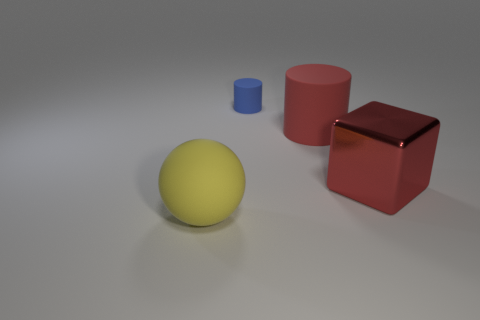What is the color of the matte object that is left of the big red cylinder and in front of the small thing?
Provide a short and direct response. Yellow. What number of other things are there of the same shape as the large yellow thing?
Your answer should be compact. 0. There is a big matte thing behind the red metallic object; is its color the same as the big thing that is to the right of the red matte cylinder?
Provide a short and direct response. Yes. There is a rubber thing that is on the right side of the tiny blue cylinder; is it the same size as the matte object behind the large red cylinder?
Ensure brevity in your answer.  No. Is there anything else that is the same material as the small cylinder?
Provide a short and direct response. Yes. What material is the red cube on the right side of the cylinder to the left of the large rubber thing to the right of the big ball?
Your answer should be compact. Metal. Does the blue object have the same shape as the large red matte thing?
Offer a very short reply. Yes. What material is the other object that is the same shape as the tiny thing?
Ensure brevity in your answer.  Rubber. How many large shiny blocks are the same color as the big matte cylinder?
Your answer should be compact. 1. What is the size of the yellow thing that is the same material as the big red cylinder?
Offer a terse response. Large. 